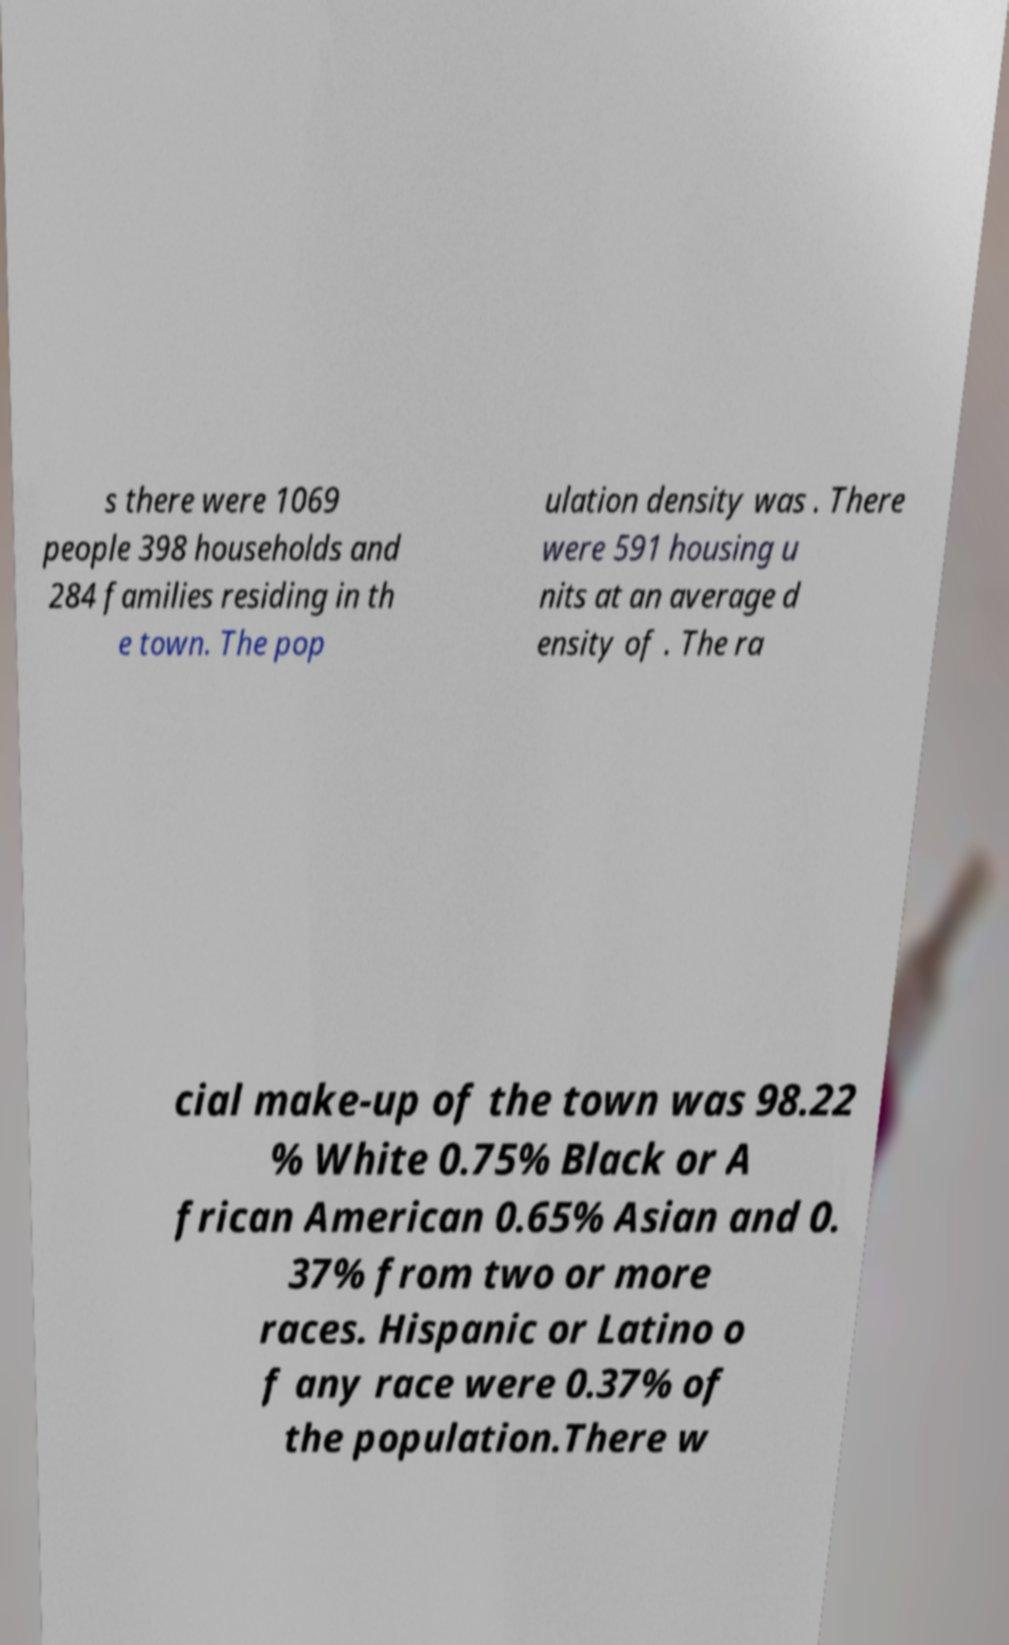Please identify and transcribe the text found in this image. s there were 1069 people 398 households and 284 families residing in th e town. The pop ulation density was . There were 591 housing u nits at an average d ensity of . The ra cial make-up of the town was 98.22 % White 0.75% Black or A frican American 0.65% Asian and 0. 37% from two or more races. Hispanic or Latino o f any race were 0.37% of the population.There w 